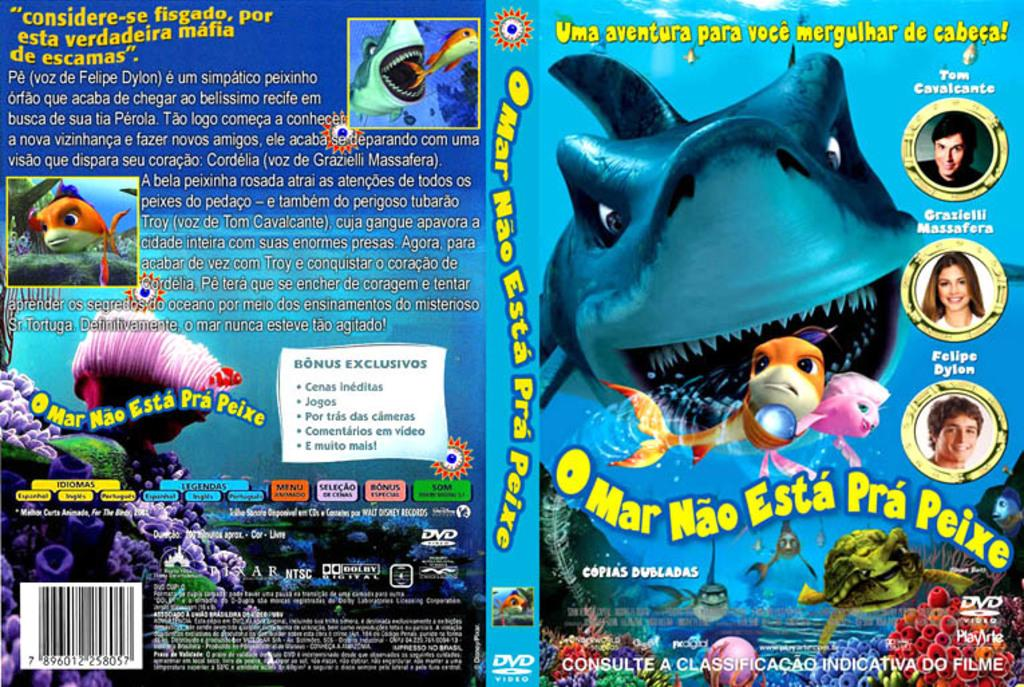What is present on the poster in the image? There is a poster in the image. What can be seen on the poster besides the poster itself? The poster has text written on it. What type of machine is depicted on the poster? There is no machine depicted on the poster; it only has text written on it. How many dimes are visible on the poster? There are no dimes present on the poster; it only has text written on it. 